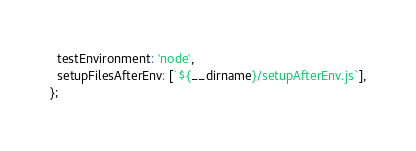<code> <loc_0><loc_0><loc_500><loc_500><_JavaScript_>  testEnvironment: 'node',
  setupFilesAfterEnv: [`${__dirname}/setupAfterEnv.js`],
};
</code> 